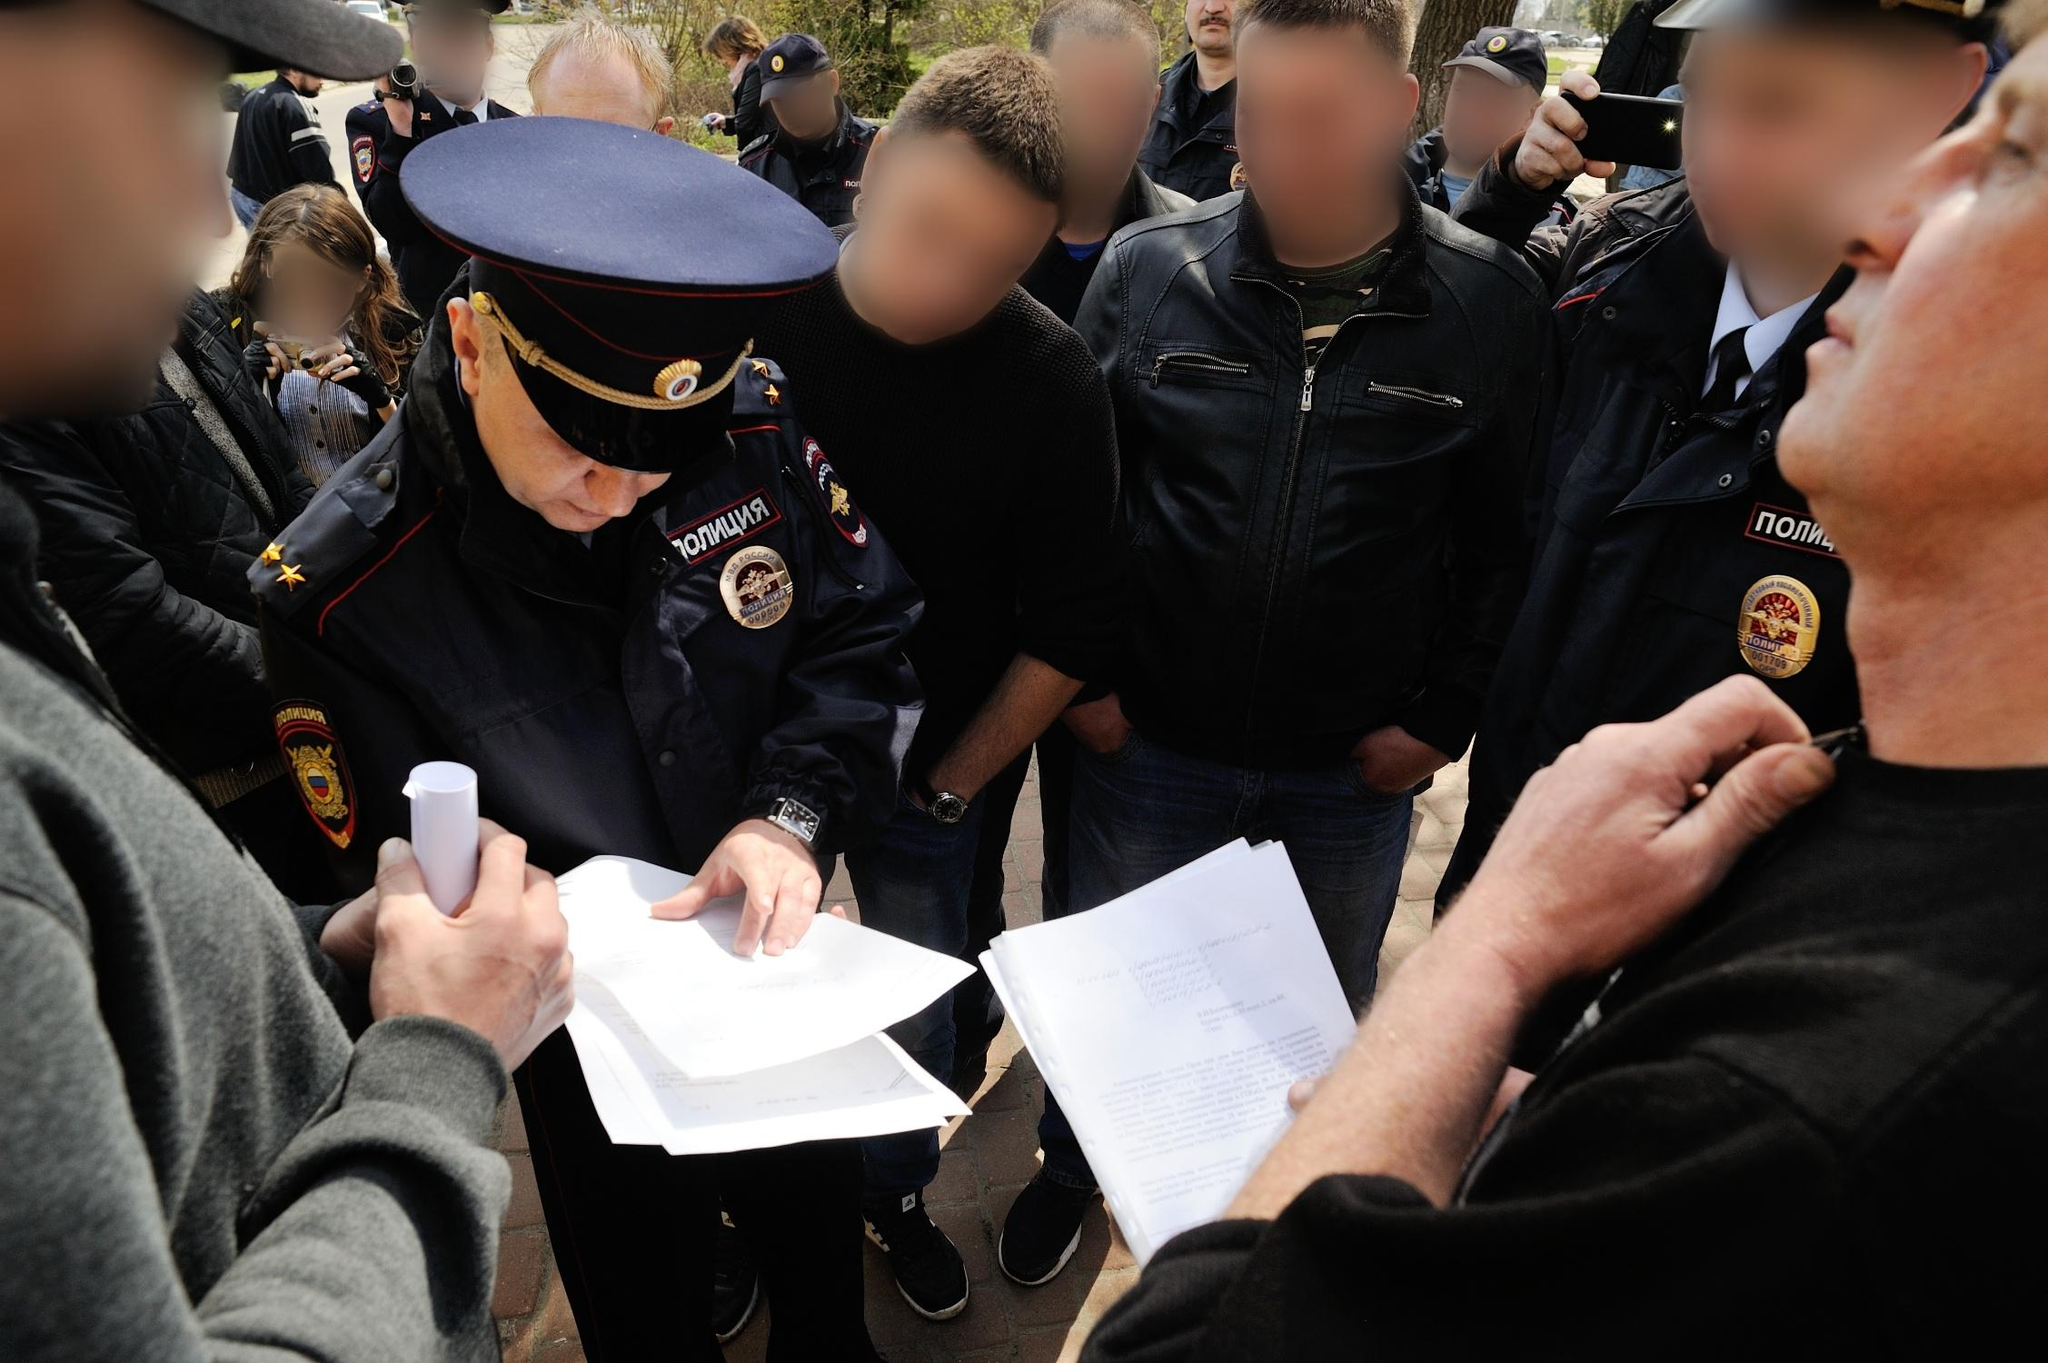Construct a detailed narrative about a possible backstory involving the officer and people around him. The officer, recognized as Captain Ivanov, is known for his meticulous record-keeping and dedication to public service. Today, he is amidst a stirring occasion—a community leader's arrest on accusations that have divided public opinion. As Captain Ivanov stands surrounded by concerned citizens and fellow officers, he meticulously documents witness accounts and statements. To his left, Mr. Petrov, a fervent supporter of the community leader, presents his testimony, insisting on the leader's innocence. On his right, Mr. Sidorov, advocating for accountability, supports the proceedings. The crowd behind them embodies the town's split perspective, watching closely as Captain Ivanov's pen captures the essence of their divided sentiments. With every stroke, he not only records facts but weaves the narrative of a community at a crossroads, ensuring history captures the complexities and emotions of this defining moment. 